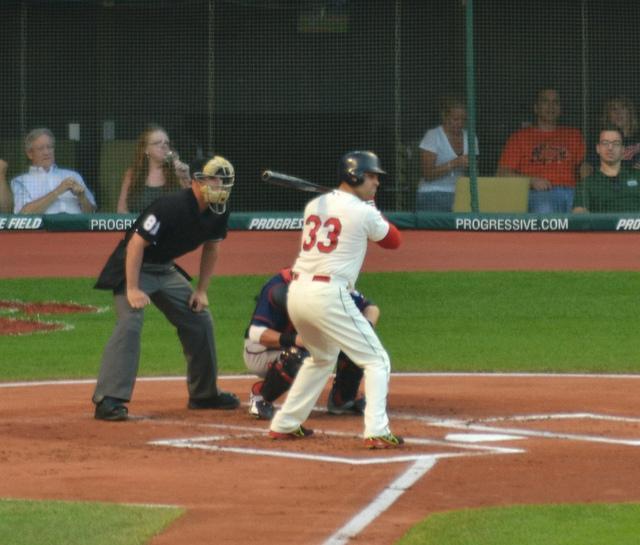How many people are there?
Give a very brief answer. 8. 